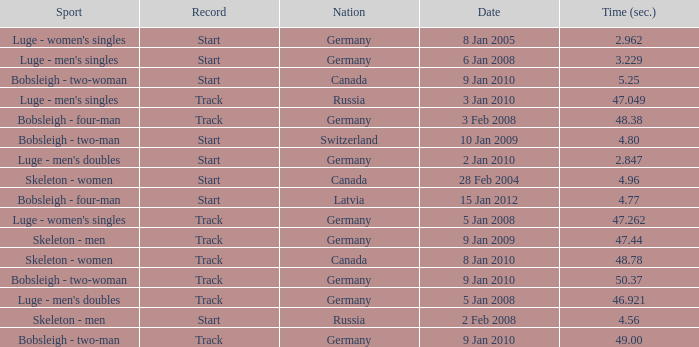Which nation had a time of 48.38? Germany. 